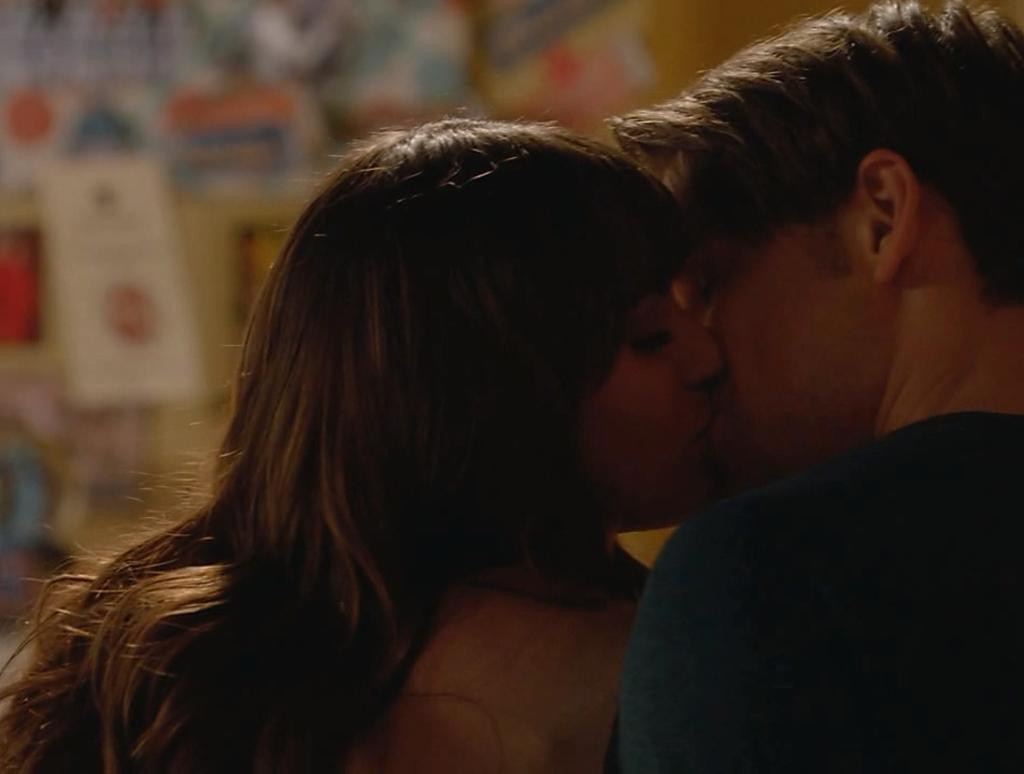How many people are in the image? There are two persons in the image. What are the two persons doing in the image? The two persons are kissing. Can you describe the background of the image? The background of the image is blurred. What book is the person on the left holding in the image? There is no book present in the image. Is there a lamp visible in the image? There is no lamp present in the image. 